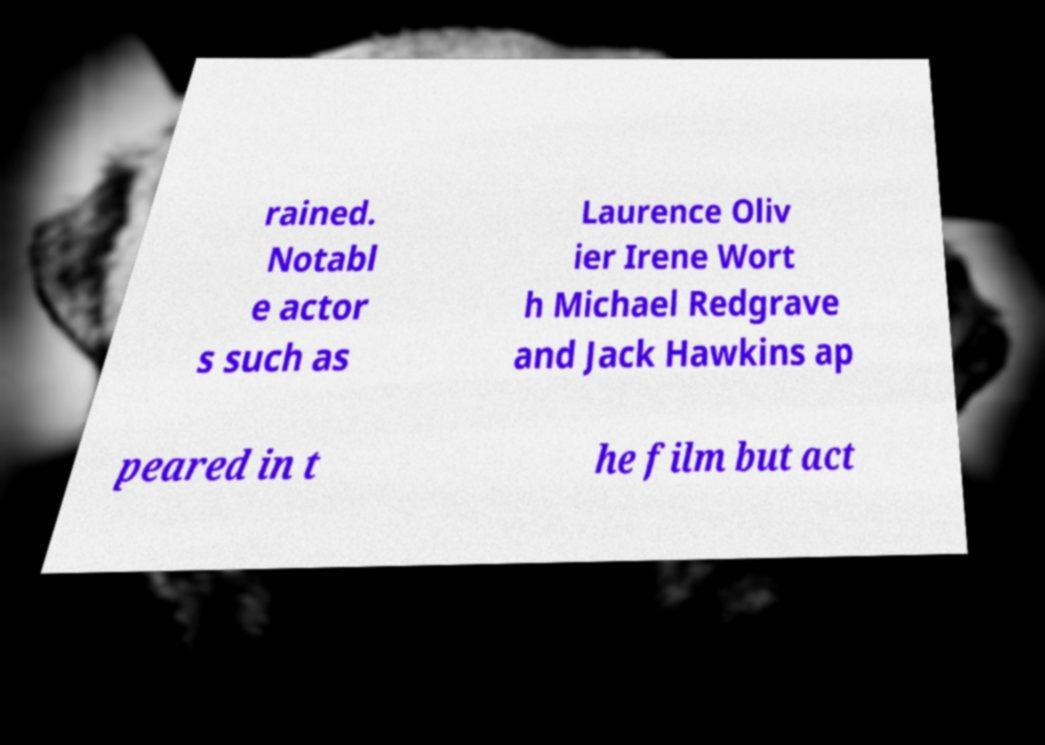For documentation purposes, I need the text within this image transcribed. Could you provide that? rained. Notabl e actor s such as Laurence Oliv ier Irene Wort h Michael Redgrave and Jack Hawkins ap peared in t he film but act 